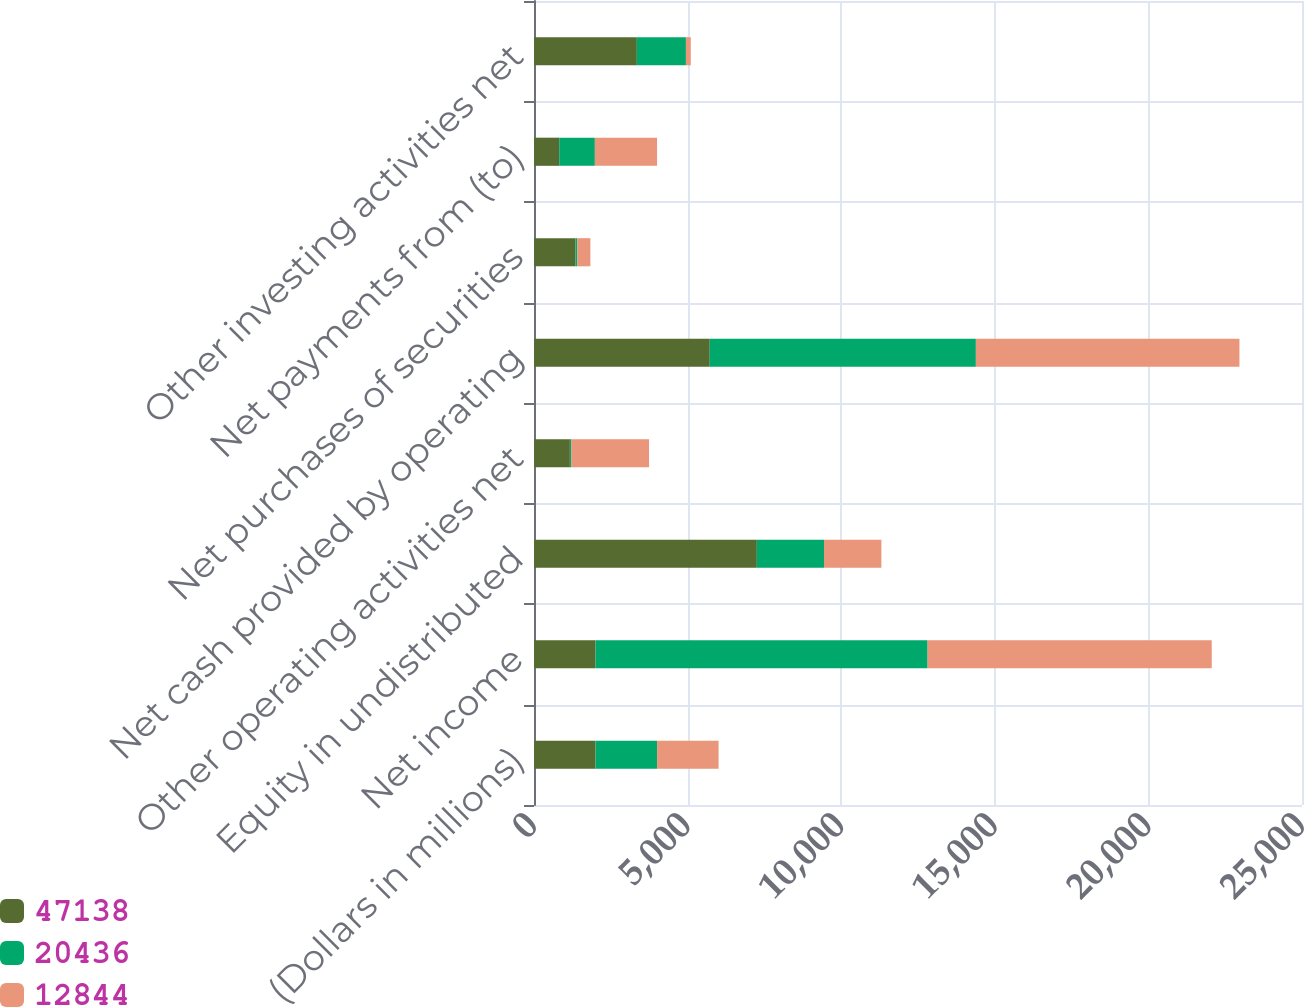Convert chart to OTSL. <chart><loc_0><loc_0><loc_500><loc_500><stacked_bar_chart><ecel><fcel>(Dollars in millions)<fcel>Net income<fcel>Equity in undistributed<fcel>Other operating activities net<fcel>Net cash provided by operating<fcel>Net purchases of securities<fcel>Net payments from (to)<fcel>Other investing activities net<nl><fcel>47138<fcel>2004<fcel>2003<fcel>7254<fcel>1168<fcel>5721<fcel>1348<fcel>821<fcel>3348<nl><fcel>20436<fcel>2003<fcel>10810<fcel>2187<fcel>40<fcel>8663<fcel>59<fcel>1160<fcel>1597<nl><fcel>12844<fcel>2002<fcel>9249<fcel>1867<fcel>2537<fcel>8579<fcel>428<fcel>2025<fcel>158<nl></chart> 